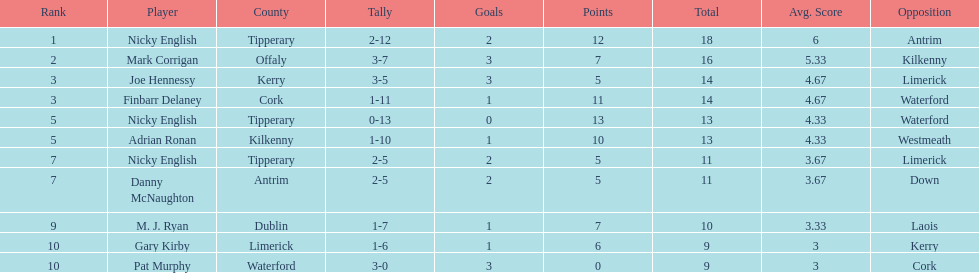Who was the top ranked player in a single game? Nicky English. 